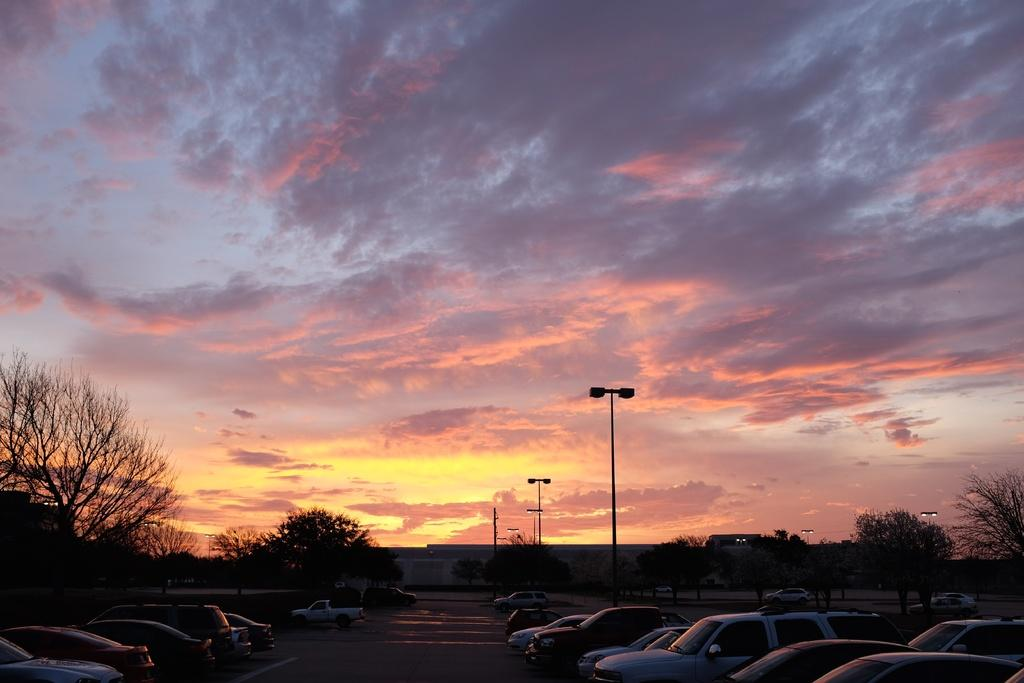What can be seen in the sky in the image? The sky with clouds is visible in the image. What type of structures are present along the street in the image? There are street poles and buildings in the image. What type of lighting is present along the street in the image? Street lights are present in the image. What type of vegetation is visible in the image? Trees are visible in the image. What type of objects are on the floor in the image? Motor vehicles are on the floor in the image. What type of linen is used to cover the motor vehicles in the image? There is no linen present in the image; the motor vehicles are not covered. Can you tell me how many people are sleeping on the street in the image? There is no one sleeping on the street in the image. 